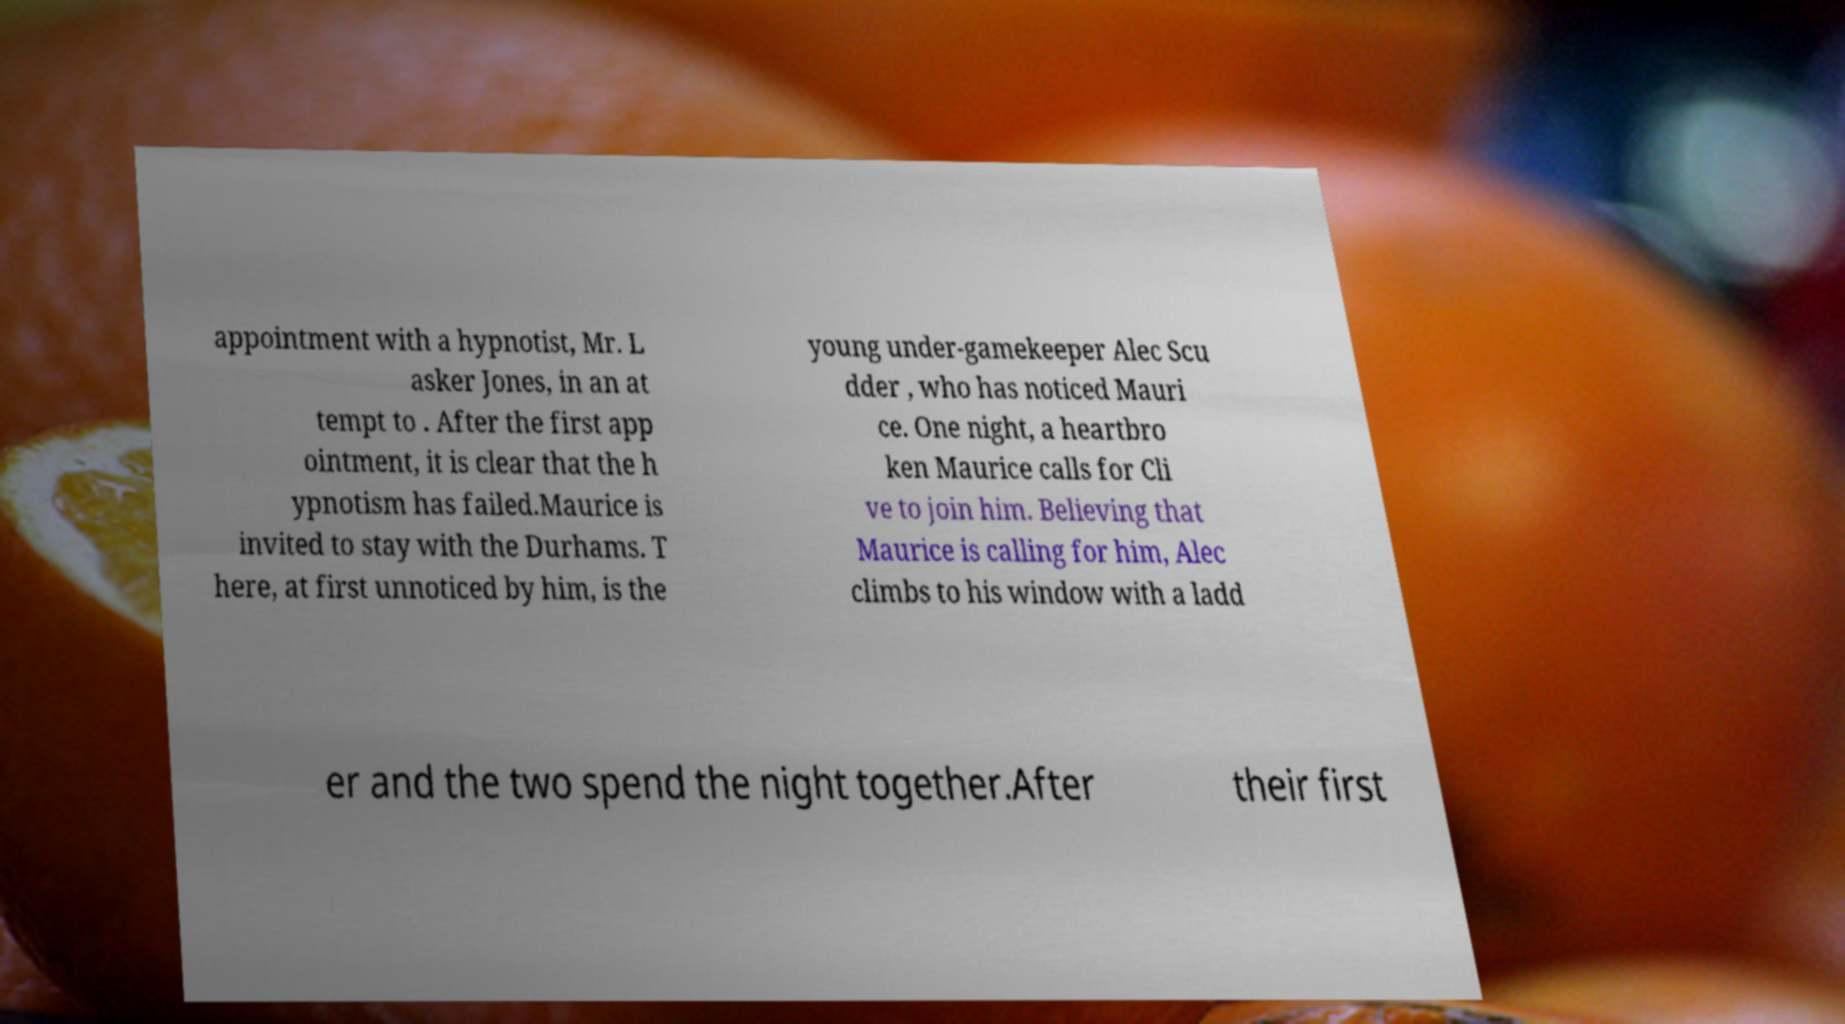Could you assist in decoding the text presented in this image and type it out clearly? appointment with a hypnotist, Mr. L asker Jones, in an at tempt to . After the first app ointment, it is clear that the h ypnotism has failed.Maurice is invited to stay with the Durhams. T here, at first unnoticed by him, is the young under-gamekeeper Alec Scu dder , who has noticed Mauri ce. One night, a heartbro ken Maurice calls for Cli ve to join him. Believing that Maurice is calling for him, Alec climbs to his window with a ladd er and the two spend the night together.After their first 